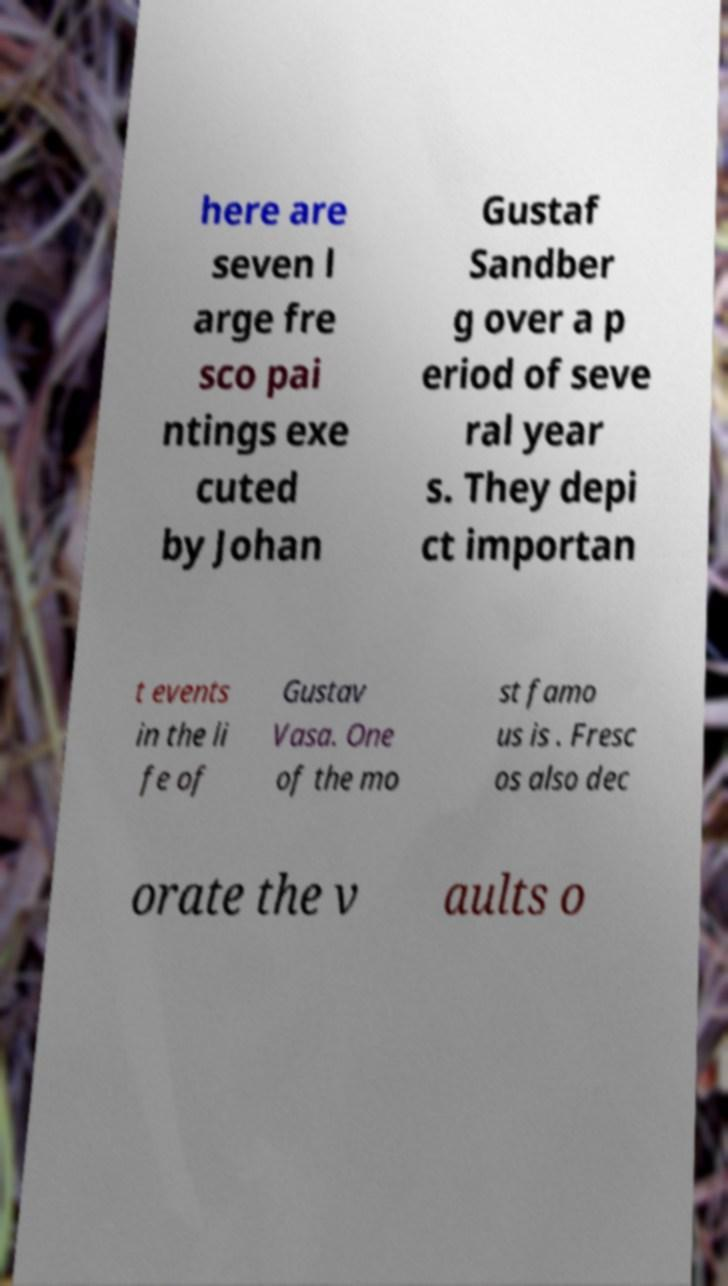For documentation purposes, I need the text within this image transcribed. Could you provide that? here are seven l arge fre sco pai ntings exe cuted by Johan Gustaf Sandber g over a p eriod of seve ral year s. They depi ct importan t events in the li fe of Gustav Vasa. One of the mo st famo us is . Fresc os also dec orate the v aults o 